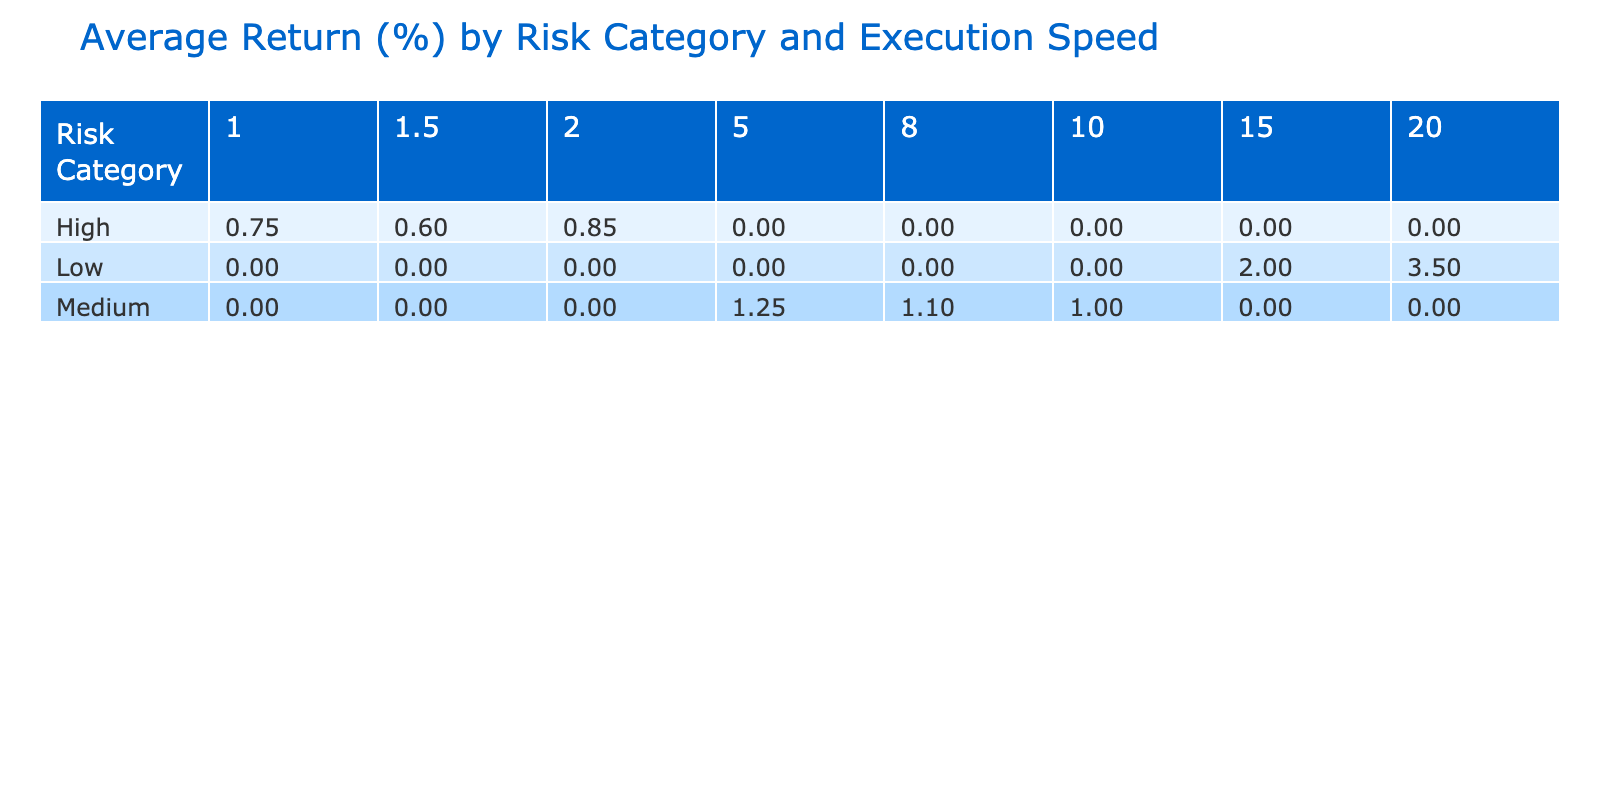What is the average return for the Low-risk category with an execution speed of 20 ms? The average return for the Low-risk category with an execution speed of 20 ms is listed directly in the table, which is 3.50%.
Answer: 3.50% Which risk category has the highest average return at the fastest execution speed of 1 ms? In the table, the average return for the High-risk category at 1 ms execution speed is 0.75%, which is the only value in that execution speed category. Therefore, it has the highest return.
Answer: 0.75% What is the average return for Medium-risk strategies? To calculate the average return for Medium-risk strategies, look for all the entries under this category. We have two: 1.25% from Statistical Arbitrage and 1.10% from Mean Reversion. So, the average return is (1.25 + 1.10) / 2 = 1.175%.
Answer: 1.18% Is the average return for News Sentiment Trading higher than for Market Making? Comparing the average returns, News Sentiment Trading has an average return of 0.85%, while Market Making has a return of 0.60%. Since 0.85% is greater than 0.60%, the statement is true.
Answer: Yes What is the difference in average return between Low-risk Long-Term Investing and Medium-risk Pairs Trading? The average return for Low-risk Long-Term Investing is 3.50%, and for Medium-risk Pairs Trading, it's 1.00%. The difference is calculated as 3.50% - 1.00% = 2.50%.
Answer: 2.50% 